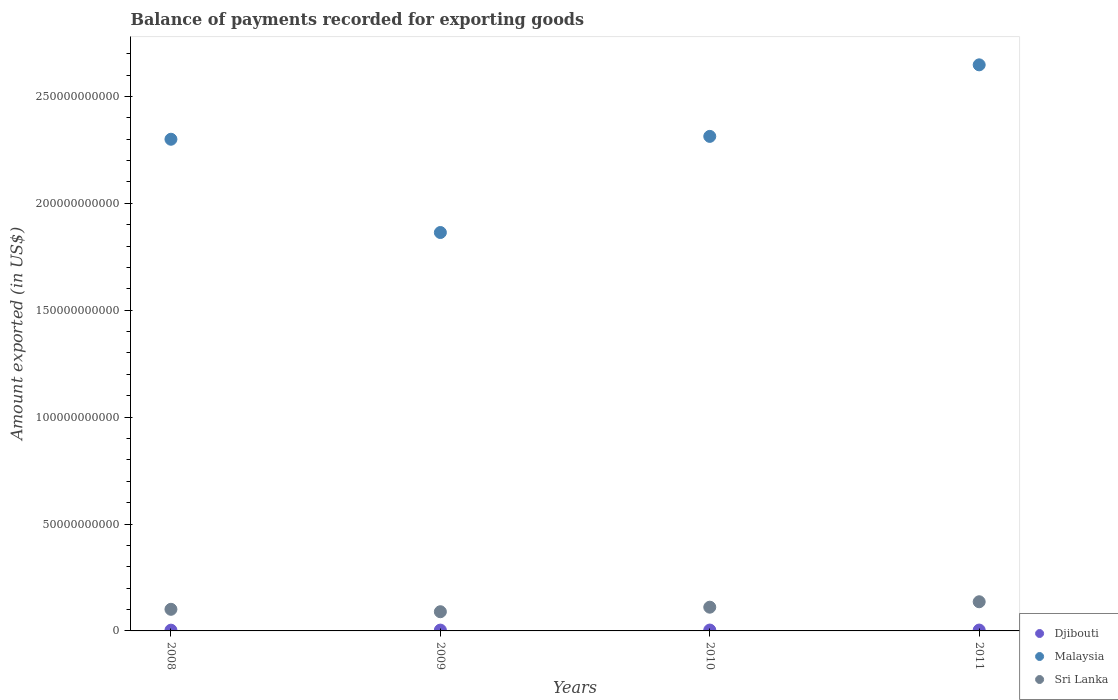How many different coloured dotlines are there?
Keep it short and to the point. 3. Is the number of dotlines equal to the number of legend labels?
Your answer should be very brief. Yes. What is the amount exported in Djibouti in 2009?
Ensure brevity in your answer.  3.86e+08. Across all years, what is the maximum amount exported in Djibouti?
Offer a very short reply. 4.06e+08. Across all years, what is the minimum amount exported in Djibouti?
Make the answer very short. 3.53e+08. In which year was the amount exported in Djibouti minimum?
Give a very brief answer. 2008. What is the total amount exported in Sri Lanka in the graph?
Ensure brevity in your answer.  4.38e+1. What is the difference between the amount exported in Malaysia in 2009 and that in 2010?
Ensure brevity in your answer.  -4.50e+1. What is the difference between the amount exported in Djibouti in 2008 and the amount exported in Malaysia in 2010?
Offer a very short reply. -2.31e+11. What is the average amount exported in Sri Lanka per year?
Your answer should be very brief. 1.10e+1. In the year 2011, what is the difference between the amount exported in Malaysia and amount exported in Sri Lanka?
Your response must be concise. 2.51e+11. In how many years, is the amount exported in Malaysia greater than 50000000000 US$?
Offer a terse response. 4. What is the ratio of the amount exported in Sri Lanka in 2009 to that in 2010?
Offer a very short reply. 0.81. Is the amount exported in Djibouti in 2010 less than that in 2011?
Provide a short and direct response. No. What is the difference between the highest and the second highest amount exported in Sri Lanka?
Ensure brevity in your answer.  2.54e+09. What is the difference between the highest and the lowest amount exported in Malaysia?
Give a very brief answer. 7.84e+1. In how many years, is the amount exported in Malaysia greater than the average amount exported in Malaysia taken over all years?
Offer a terse response. 3. Is the sum of the amount exported in Djibouti in 2009 and 2010 greater than the maximum amount exported in Malaysia across all years?
Your answer should be very brief. No. Does the amount exported in Djibouti monotonically increase over the years?
Keep it short and to the point. No. Is the amount exported in Malaysia strictly greater than the amount exported in Sri Lanka over the years?
Give a very brief answer. Yes. Is the amount exported in Djibouti strictly less than the amount exported in Malaysia over the years?
Ensure brevity in your answer.  Yes. How many years are there in the graph?
Offer a very short reply. 4. What is the difference between two consecutive major ticks on the Y-axis?
Your answer should be very brief. 5.00e+1. Does the graph contain any zero values?
Offer a very short reply. No. Where does the legend appear in the graph?
Offer a terse response. Bottom right. How are the legend labels stacked?
Offer a very short reply. Vertical. What is the title of the graph?
Your answer should be compact. Balance of payments recorded for exporting goods. Does "Iceland" appear as one of the legend labels in the graph?
Your answer should be very brief. No. What is the label or title of the X-axis?
Make the answer very short. Years. What is the label or title of the Y-axis?
Give a very brief answer. Amount exported (in US$). What is the Amount exported (in US$) in Djibouti in 2008?
Give a very brief answer. 3.53e+08. What is the Amount exported (in US$) in Malaysia in 2008?
Ensure brevity in your answer.  2.30e+11. What is the Amount exported (in US$) of Sri Lanka in 2008?
Your answer should be very brief. 1.01e+1. What is the Amount exported (in US$) of Djibouti in 2009?
Your answer should be compact. 3.86e+08. What is the Amount exported (in US$) of Malaysia in 2009?
Provide a short and direct response. 1.86e+11. What is the Amount exported (in US$) in Sri Lanka in 2009?
Offer a very short reply. 8.98e+09. What is the Amount exported (in US$) in Djibouti in 2010?
Keep it short and to the point. 4.06e+08. What is the Amount exported (in US$) in Malaysia in 2010?
Your answer should be compact. 2.31e+11. What is the Amount exported (in US$) of Sri Lanka in 2010?
Offer a terse response. 1.11e+1. What is the Amount exported (in US$) of Djibouti in 2011?
Ensure brevity in your answer.  4.04e+08. What is the Amount exported (in US$) in Malaysia in 2011?
Offer a very short reply. 2.65e+11. What is the Amount exported (in US$) of Sri Lanka in 2011?
Make the answer very short. 1.36e+1. Across all years, what is the maximum Amount exported (in US$) of Djibouti?
Ensure brevity in your answer.  4.06e+08. Across all years, what is the maximum Amount exported (in US$) of Malaysia?
Make the answer very short. 2.65e+11. Across all years, what is the maximum Amount exported (in US$) in Sri Lanka?
Your answer should be very brief. 1.36e+1. Across all years, what is the minimum Amount exported (in US$) of Djibouti?
Your answer should be compact. 3.53e+08. Across all years, what is the minimum Amount exported (in US$) in Malaysia?
Offer a terse response. 1.86e+11. Across all years, what is the minimum Amount exported (in US$) of Sri Lanka?
Your answer should be very brief. 8.98e+09. What is the total Amount exported (in US$) of Djibouti in the graph?
Provide a succinct answer. 1.55e+09. What is the total Amount exported (in US$) of Malaysia in the graph?
Provide a short and direct response. 9.12e+11. What is the total Amount exported (in US$) of Sri Lanka in the graph?
Your answer should be very brief. 4.38e+1. What is the difference between the Amount exported (in US$) in Djibouti in 2008 and that in 2009?
Your answer should be very brief. -3.31e+07. What is the difference between the Amount exported (in US$) of Malaysia in 2008 and that in 2009?
Your answer should be compact. 4.36e+1. What is the difference between the Amount exported (in US$) in Sri Lanka in 2008 and that in 2009?
Your answer should be very brief. 1.14e+09. What is the difference between the Amount exported (in US$) of Djibouti in 2008 and that in 2010?
Your response must be concise. -5.36e+07. What is the difference between the Amount exported (in US$) in Malaysia in 2008 and that in 2010?
Your answer should be compact. -1.34e+09. What is the difference between the Amount exported (in US$) of Sri Lanka in 2008 and that in 2010?
Your answer should be compact. -9.87e+08. What is the difference between the Amount exported (in US$) of Djibouti in 2008 and that in 2011?
Provide a short and direct response. -5.09e+07. What is the difference between the Amount exported (in US$) of Malaysia in 2008 and that in 2011?
Your answer should be very brief. -3.48e+1. What is the difference between the Amount exported (in US$) in Sri Lanka in 2008 and that in 2011?
Ensure brevity in your answer.  -3.53e+09. What is the difference between the Amount exported (in US$) of Djibouti in 2009 and that in 2010?
Your answer should be very brief. -2.05e+07. What is the difference between the Amount exported (in US$) in Malaysia in 2009 and that in 2010?
Provide a short and direct response. -4.50e+1. What is the difference between the Amount exported (in US$) in Sri Lanka in 2009 and that in 2010?
Provide a short and direct response. -2.12e+09. What is the difference between the Amount exported (in US$) of Djibouti in 2009 and that in 2011?
Give a very brief answer. -1.78e+07. What is the difference between the Amount exported (in US$) of Malaysia in 2009 and that in 2011?
Your answer should be very brief. -7.84e+1. What is the difference between the Amount exported (in US$) of Sri Lanka in 2009 and that in 2011?
Your response must be concise. -4.67e+09. What is the difference between the Amount exported (in US$) in Djibouti in 2010 and that in 2011?
Ensure brevity in your answer.  2.64e+06. What is the difference between the Amount exported (in US$) in Malaysia in 2010 and that in 2011?
Provide a short and direct response. -3.35e+1. What is the difference between the Amount exported (in US$) of Sri Lanka in 2010 and that in 2011?
Offer a very short reply. -2.54e+09. What is the difference between the Amount exported (in US$) in Djibouti in 2008 and the Amount exported (in US$) in Malaysia in 2009?
Make the answer very short. -1.86e+11. What is the difference between the Amount exported (in US$) of Djibouti in 2008 and the Amount exported (in US$) of Sri Lanka in 2009?
Ensure brevity in your answer.  -8.62e+09. What is the difference between the Amount exported (in US$) in Malaysia in 2008 and the Amount exported (in US$) in Sri Lanka in 2009?
Offer a terse response. 2.21e+11. What is the difference between the Amount exported (in US$) of Djibouti in 2008 and the Amount exported (in US$) of Malaysia in 2010?
Your answer should be compact. -2.31e+11. What is the difference between the Amount exported (in US$) of Djibouti in 2008 and the Amount exported (in US$) of Sri Lanka in 2010?
Ensure brevity in your answer.  -1.07e+1. What is the difference between the Amount exported (in US$) of Malaysia in 2008 and the Amount exported (in US$) of Sri Lanka in 2010?
Keep it short and to the point. 2.19e+11. What is the difference between the Amount exported (in US$) in Djibouti in 2008 and the Amount exported (in US$) in Malaysia in 2011?
Make the answer very short. -2.64e+11. What is the difference between the Amount exported (in US$) of Djibouti in 2008 and the Amount exported (in US$) of Sri Lanka in 2011?
Provide a succinct answer. -1.33e+1. What is the difference between the Amount exported (in US$) in Malaysia in 2008 and the Amount exported (in US$) in Sri Lanka in 2011?
Keep it short and to the point. 2.16e+11. What is the difference between the Amount exported (in US$) in Djibouti in 2009 and the Amount exported (in US$) in Malaysia in 2010?
Offer a terse response. -2.31e+11. What is the difference between the Amount exported (in US$) in Djibouti in 2009 and the Amount exported (in US$) in Sri Lanka in 2010?
Your answer should be compact. -1.07e+1. What is the difference between the Amount exported (in US$) of Malaysia in 2009 and the Amount exported (in US$) of Sri Lanka in 2010?
Ensure brevity in your answer.  1.75e+11. What is the difference between the Amount exported (in US$) of Djibouti in 2009 and the Amount exported (in US$) of Malaysia in 2011?
Offer a very short reply. -2.64e+11. What is the difference between the Amount exported (in US$) of Djibouti in 2009 and the Amount exported (in US$) of Sri Lanka in 2011?
Give a very brief answer. -1.33e+1. What is the difference between the Amount exported (in US$) of Malaysia in 2009 and the Amount exported (in US$) of Sri Lanka in 2011?
Offer a terse response. 1.73e+11. What is the difference between the Amount exported (in US$) in Djibouti in 2010 and the Amount exported (in US$) in Malaysia in 2011?
Make the answer very short. -2.64e+11. What is the difference between the Amount exported (in US$) in Djibouti in 2010 and the Amount exported (in US$) in Sri Lanka in 2011?
Make the answer very short. -1.32e+1. What is the difference between the Amount exported (in US$) in Malaysia in 2010 and the Amount exported (in US$) in Sri Lanka in 2011?
Make the answer very short. 2.18e+11. What is the average Amount exported (in US$) of Djibouti per year?
Your response must be concise. 3.87e+08. What is the average Amount exported (in US$) in Malaysia per year?
Give a very brief answer. 2.28e+11. What is the average Amount exported (in US$) in Sri Lanka per year?
Offer a terse response. 1.10e+1. In the year 2008, what is the difference between the Amount exported (in US$) in Djibouti and Amount exported (in US$) in Malaysia?
Make the answer very short. -2.30e+11. In the year 2008, what is the difference between the Amount exported (in US$) in Djibouti and Amount exported (in US$) in Sri Lanka?
Give a very brief answer. -9.76e+09. In the year 2008, what is the difference between the Amount exported (in US$) of Malaysia and Amount exported (in US$) of Sri Lanka?
Keep it short and to the point. 2.20e+11. In the year 2009, what is the difference between the Amount exported (in US$) in Djibouti and Amount exported (in US$) in Malaysia?
Offer a terse response. -1.86e+11. In the year 2009, what is the difference between the Amount exported (in US$) in Djibouti and Amount exported (in US$) in Sri Lanka?
Make the answer very short. -8.59e+09. In the year 2009, what is the difference between the Amount exported (in US$) in Malaysia and Amount exported (in US$) in Sri Lanka?
Your answer should be compact. 1.77e+11. In the year 2010, what is the difference between the Amount exported (in US$) of Djibouti and Amount exported (in US$) of Malaysia?
Offer a terse response. -2.31e+11. In the year 2010, what is the difference between the Amount exported (in US$) in Djibouti and Amount exported (in US$) in Sri Lanka?
Give a very brief answer. -1.07e+1. In the year 2010, what is the difference between the Amount exported (in US$) of Malaysia and Amount exported (in US$) of Sri Lanka?
Offer a terse response. 2.20e+11. In the year 2011, what is the difference between the Amount exported (in US$) of Djibouti and Amount exported (in US$) of Malaysia?
Your answer should be compact. -2.64e+11. In the year 2011, what is the difference between the Amount exported (in US$) in Djibouti and Amount exported (in US$) in Sri Lanka?
Offer a terse response. -1.32e+1. In the year 2011, what is the difference between the Amount exported (in US$) of Malaysia and Amount exported (in US$) of Sri Lanka?
Offer a very short reply. 2.51e+11. What is the ratio of the Amount exported (in US$) of Djibouti in 2008 to that in 2009?
Offer a terse response. 0.91. What is the ratio of the Amount exported (in US$) in Malaysia in 2008 to that in 2009?
Offer a very short reply. 1.23. What is the ratio of the Amount exported (in US$) in Sri Lanka in 2008 to that in 2009?
Offer a very short reply. 1.13. What is the ratio of the Amount exported (in US$) in Djibouti in 2008 to that in 2010?
Offer a terse response. 0.87. What is the ratio of the Amount exported (in US$) in Sri Lanka in 2008 to that in 2010?
Keep it short and to the point. 0.91. What is the ratio of the Amount exported (in US$) in Djibouti in 2008 to that in 2011?
Your answer should be compact. 0.87. What is the ratio of the Amount exported (in US$) in Malaysia in 2008 to that in 2011?
Offer a very short reply. 0.87. What is the ratio of the Amount exported (in US$) in Sri Lanka in 2008 to that in 2011?
Provide a short and direct response. 0.74. What is the ratio of the Amount exported (in US$) in Djibouti in 2009 to that in 2010?
Make the answer very short. 0.95. What is the ratio of the Amount exported (in US$) of Malaysia in 2009 to that in 2010?
Keep it short and to the point. 0.81. What is the ratio of the Amount exported (in US$) in Sri Lanka in 2009 to that in 2010?
Offer a very short reply. 0.81. What is the ratio of the Amount exported (in US$) of Djibouti in 2009 to that in 2011?
Offer a very short reply. 0.96. What is the ratio of the Amount exported (in US$) of Malaysia in 2009 to that in 2011?
Offer a terse response. 0.7. What is the ratio of the Amount exported (in US$) in Sri Lanka in 2009 to that in 2011?
Your answer should be compact. 0.66. What is the ratio of the Amount exported (in US$) of Malaysia in 2010 to that in 2011?
Ensure brevity in your answer.  0.87. What is the ratio of the Amount exported (in US$) in Sri Lanka in 2010 to that in 2011?
Your response must be concise. 0.81. What is the difference between the highest and the second highest Amount exported (in US$) in Djibouti?
Provide a succinct answer. 2.64e+06. What is the difference between the highest and the second highest Amount exported (in US$) in Malaysia?
Your response must be concise. 3.35e+1. What is the difference between the highest and the second highest Amount exported (in US$) in Sri Lanka?
Your answer should be very brief. 2.54e+09. What is the difference between the highest and the lowest Amount exported (in US$) in Djibouti?
Provide a succinct answer. 5.36e+07. What is the difference between the highest and the lowest Amount exported (in US$) of Malaysia?
Ensure brevity in your answer.  7.84e+1. What is the difference between the highest and the lowest Amount exported (in US$) in Sri Lanka?
Provide a succinct answer. 4.67e+09. 